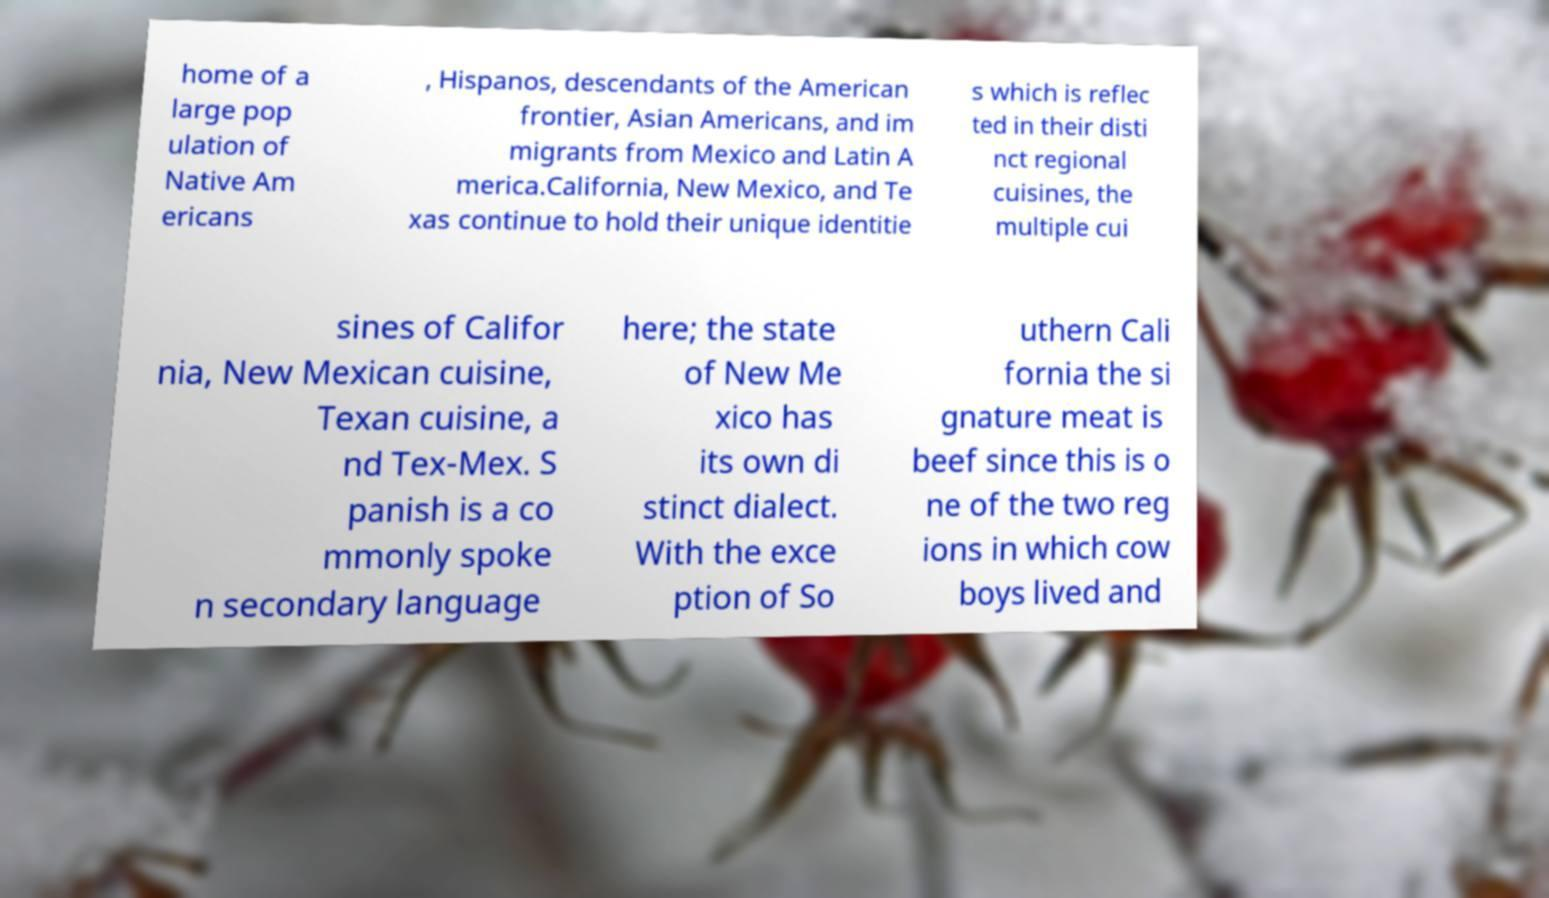Please read and relay the text visible in this image. What does it say? home of a large pop ulation of Native Am ericans , Hispanos, descendants of the American frontier, Asian Americans, and im migrants from Mexico and Latin A merica.California, New Mexico, and Te xas continue to hold their unique identitie s which is reflec ted in their disti nct regional cuisines, the multiple cui sines of Califor nia, New Mexican cuisine, Texan cuisine, a nd Tex-Mex. S panish is a co mmonly spoke n secondary language here; the state of New Me xico has its own di stinct dialect. With the exce ption of So uthern Cali fornia the si gnature meat is beef since this is o ne of the two reg ions in which cow boys lived and 